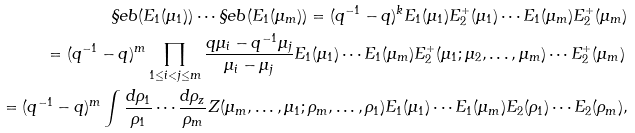<formula> <loc_0><loc_0><loc_500><loc_500>\S e b ( E _ { 1 } ( \mu _ { 1 } ) ) \cdots \S e b ( E _ { 1 } ( \mu _ { m } ) ) = ( q ^ { - 1 } - q ) ^ { k } E _ { 1 } ( \mu _ { 1 } ) E ^ { + } _ { 2 } ( \mu _ { 1 } ) \cdots E _ { 1 } ( \mu _ { m } ) E ^ { + } _ { 2 } ( \mu _ { m } ) \\ = ( q ^ { - 1 } - q ) ^ { m } \prod _ { 1 \leq i < j \leq m } \frac { q \mu _ { i } - q ^ { - 1 } \mu _ { j } } { \mu _ { i } - \mu _ { j } } E _ { 1 } ( \mu _ { 1 } ) \cdots E _ { 1 } ( \mu _ { m } ) E ^ { + } _ { 2 } ( \mu _ { 1 } ; \mu _ { 2 } , \dots , \mu _ { m } ) \cdots E ^ { + } _ { 2 } ( \mu _ { m } ) \, \\ = ( q ^ { - 1 } - q ) ^ { m } \int \frac { d \rho _ { 1 } } { \rho _ { 1 } } \cdots \frac { d \rho _ { z } } { \rho _ { m } } Z ( \mu _ { m } , \dots , \mu _ { 1 } ; \rho _ { m } , \dots , \rho _ { 1 } ) E _ { 1 } ( \mu _ { 1 } ) \cdots E _ { 1 } ( \mu _ { m } ) E _ { 2 } ( \rho _ { 1 } ) \cdots E _ { 2 } ( \rho _ { m } ) ,</formula> 